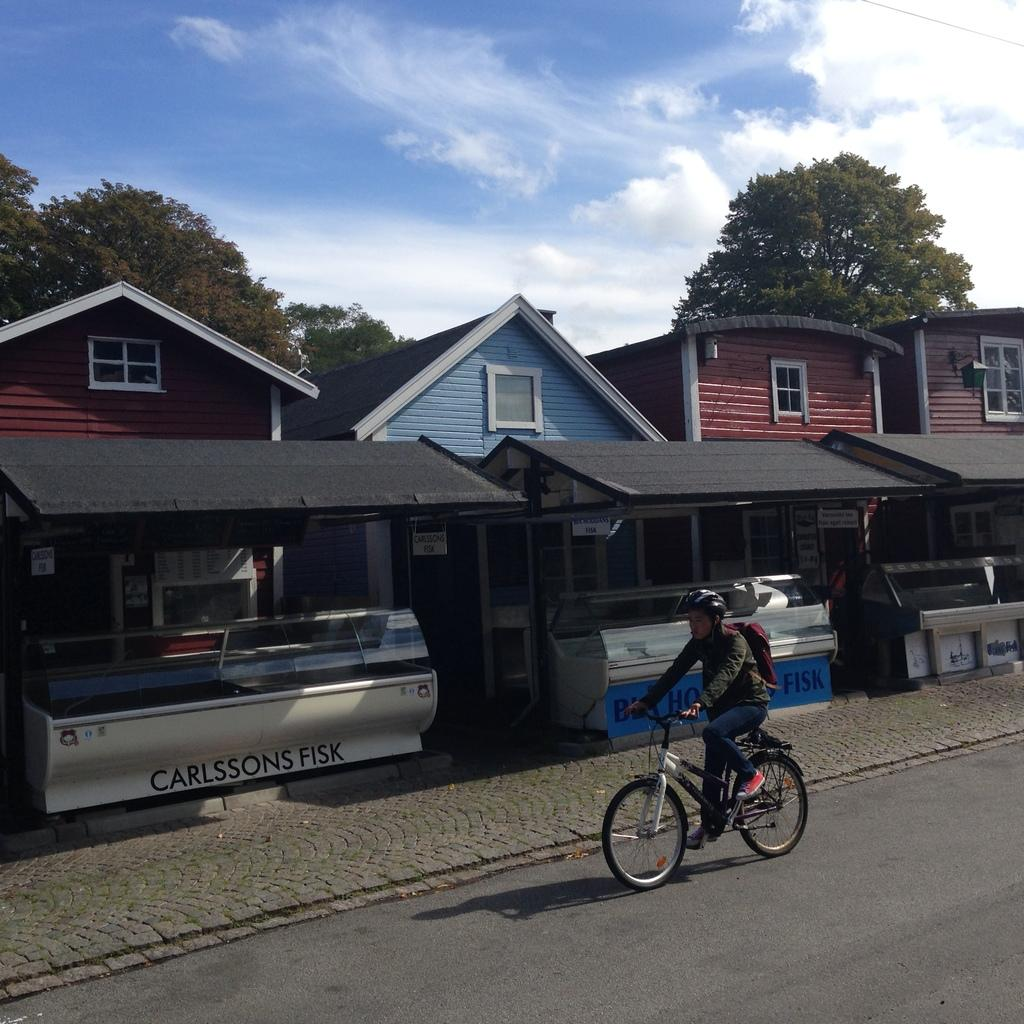What is the man in the image doing? The man is riding a bicycle. What type of location is depicted in the image? This is a road. What can be seen along the road? There are stalls on the road. What is visible in the background of the image? There are houses and trees in the background. What features can be observed on the houses? There are windows visible on the houses. What is visible in the sky in the image? The sky is visible with clouds. Can you see a cat sitting on a chair in the image? There is no cat or chair present in the image. 